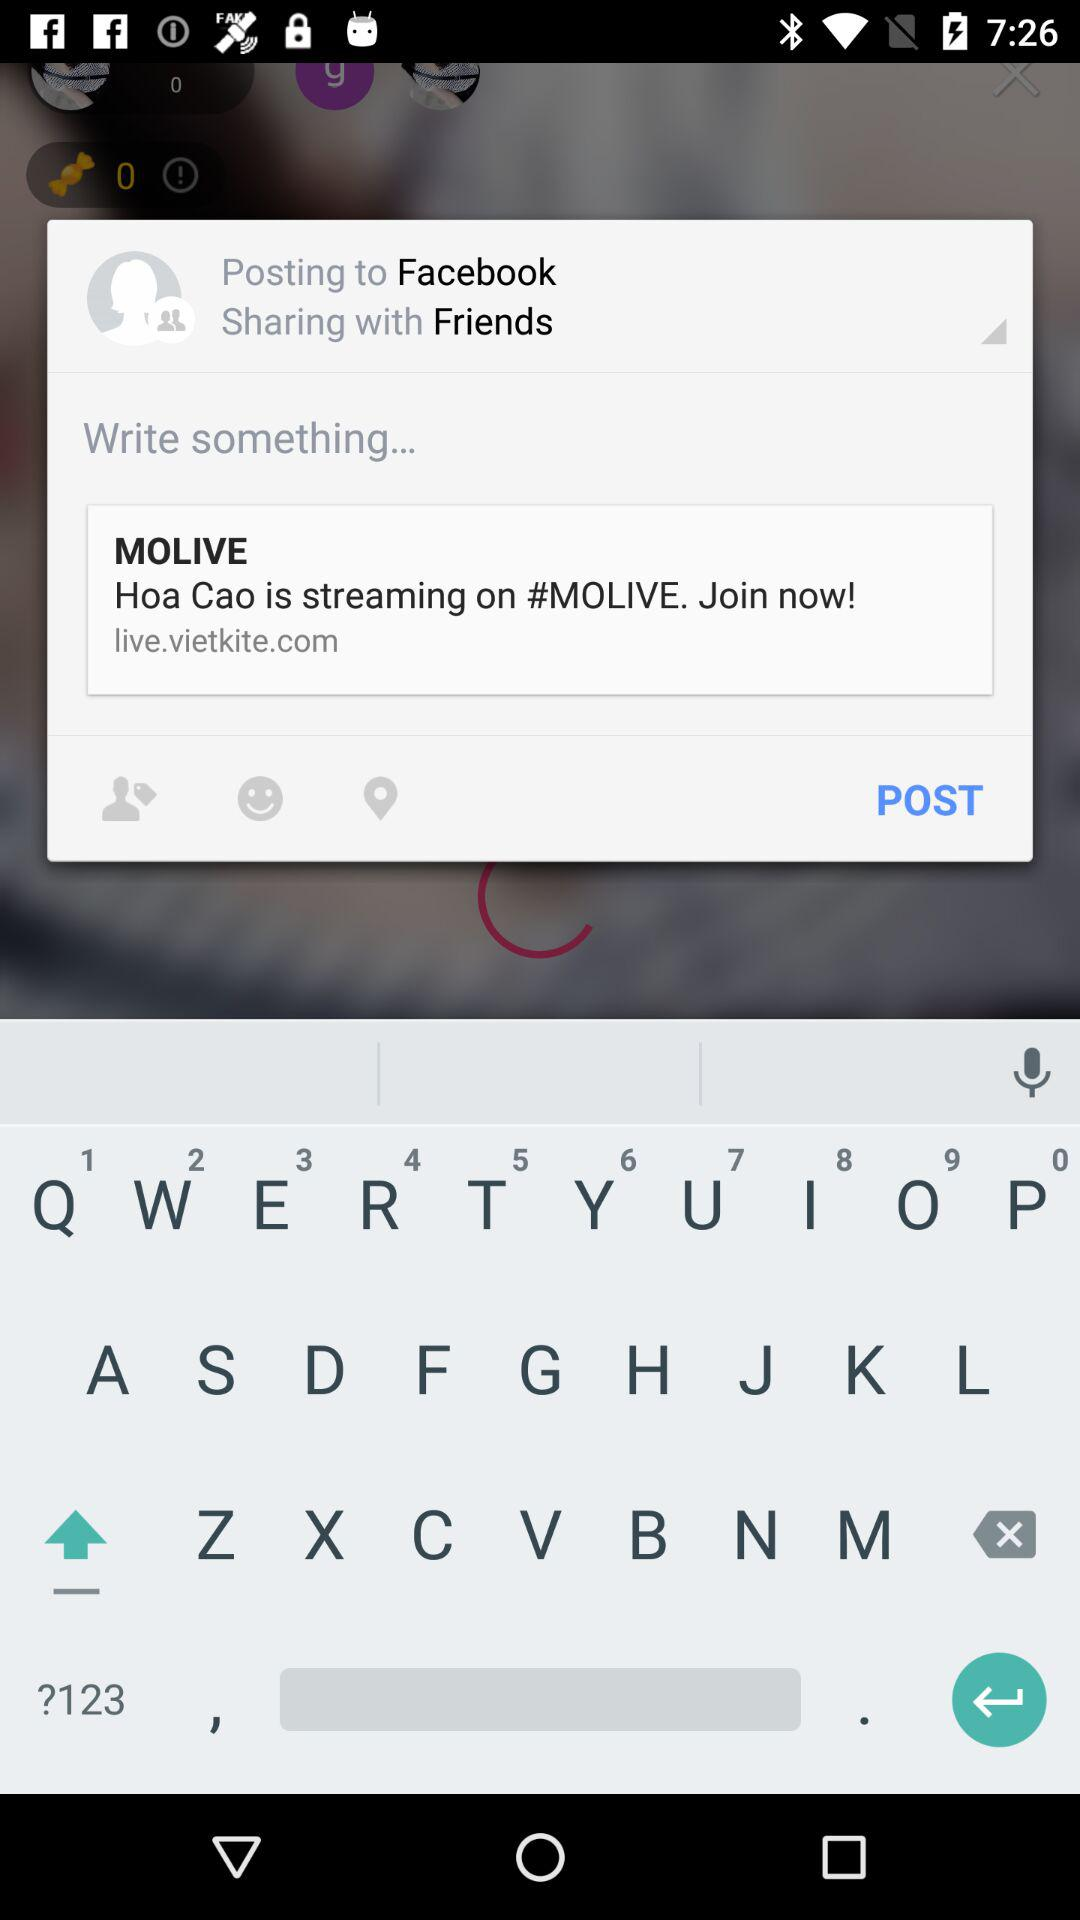How can we log in? You can log in with "Facebook". 